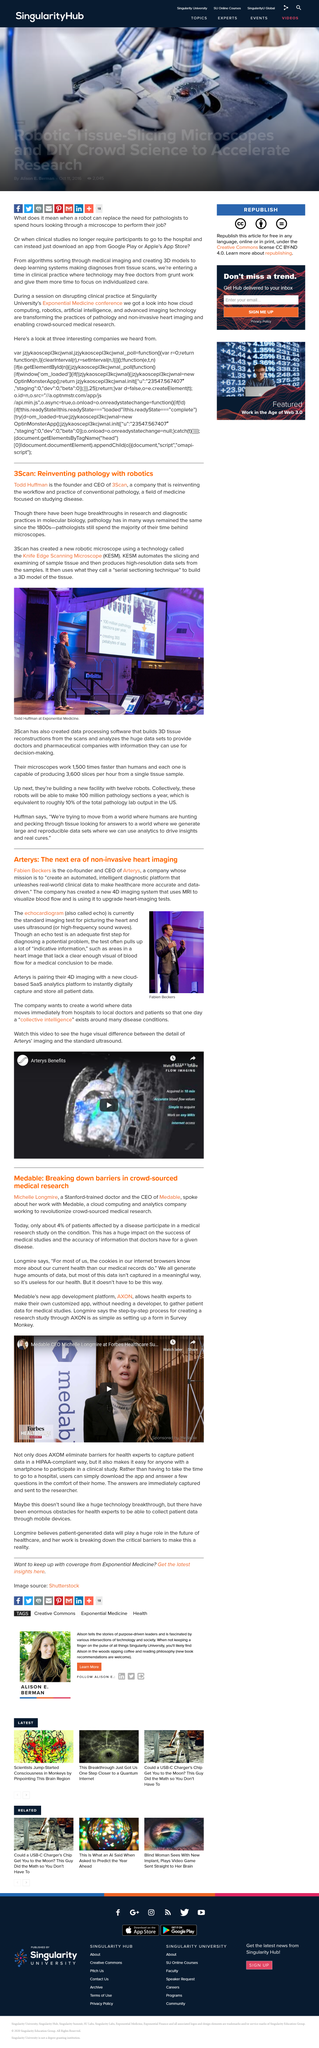Indicate a few pertinent items in this graphic. Todd Huffman is the founder and CEO of 3Scan, a company that specializes in 3D microscopy and image analysis. The Knife Edge Scanning Microscope, or KESM, is a powerful microscope that uses a narrow, intense beam of light to scan the surface of a specimen, creating detailed images of the structure and composition of the material being examined. An echocardiogram is also known as an echo. Fabien Beckers is the person depicted in the photo. Pathology is a field of medicine that focuses on the scientific study of disease, including the causes, mechanisms, and consequences of abnormal processes that disrupt the normal functioning of living organisms. 